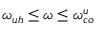<formula> <loc_0><loc_0><loc_500><loc_500>\omega _ { u h } \leq \omega \leq \omega _ { c o } ^ { u }</formula> 